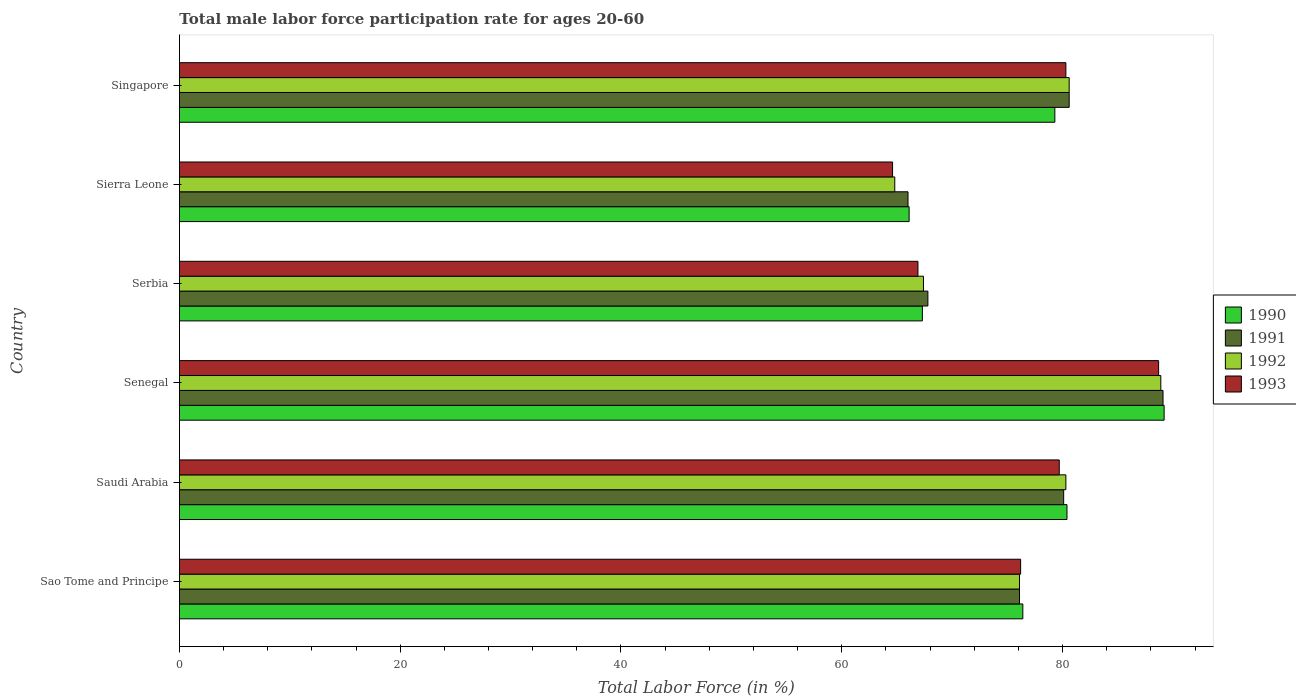Are the number of bars per tick equal to the number of legend labels?
Give a very brief answer. Yes. Are the number of bars on each tick of the Y-axis equal?
Your answer should be compact. Yes. How many bars are there on the 6th tick from the top?
Offer a terse response. 4. How many bars are there on the 3rd tick from the bottom?
Your answer should be compact. 4. What is the label of the 4th group of bars from the top?
Make the answer very short. Senegal. What is the male labor force participation rate in 1992 in Senegal?
Offer a terse response. 88.9. Across all countries, what is the maximum male labor force participation rate in 1992?
Offer a terse response. 88.9. Across all countries, what is the minimum male labor force participation rate in 1993?
Offer a very short reply. 64.6. In which country was the male labor force participation rate in 1991 maximum?
Your answer should be very brief. Senegal. In which country was the male labor force participation rate in 1993 minimum?
Your answer should be very brief. Sierra Leone. What is the total male labor force participation rate in 1992 in the graph?
Your answer should be very brief. 458.1. What is the difference between the male labor force participation rate in 1993 in Saudi Arabia and that in Serbia?
Your response must be concise. 12.8. What is the difference between the male labor force participation rate in 1993 in Senegal and the male labor force participation rate in 1990 in Singapore?
Offer a very short reply. 9.4. What is the average male labor force participation rate in 1992 per country?
Your response must be concise. 76.35. What is the difference between the male labor force participation rate in 1990 and male labor force participation rate in 1992 in Singapore?
Your response must be concise. -1.3. What is the ratio of the male labor force participation rate in 1991 in Senegal to that in Singapore?
Provide a succinct answer. 1.11. Is the difference between the male labor force participation rate in 1990 in Sierra Leone and Singapore greater than the difference between the male labor force participation rate in 1992 in Sierra Leone and Singapore?
Provide a succinct answer. Yes. What is the difference between the highest and the lowest male labor force participation rate in 1993?
Offer a very short reply. 24.1. In how many countries, is the male labor force participation rate in 1990 greater than the average male labor force participation rate in 1990 taken over all countries?
Your answer should be compact. 3. Is it the case that in every country, the sum of the male labor force participation rate in 1991 and male labor force participation rate in 1990 is greater than the sum of male labor force participation rate in 1993 and male labor force participation rate in 1992?
Make the answer very short. No. What does the 4th bar from the bottom in Sierra Leone represents?
Your answer should be very brief. 1993. Is it the case that in every country, the sum of the male labor force participation rate in 1991 and male labor force participation rate in 1992 is greater than the male labor force participation rate in 1993?
Provide a succinct answer. Yes. Are all the bars in the graph horizontal?
Offer a very short reply. Yes. What is the difference between two consecutive major ticks on the X-axis?
Ensure brevity in your answer.  20. Does the graph contain any zero values?
Your answer should be compact. No. What is the title of the graph?
Your answer should be very brief. Total male labor force participation rate for ages 20-60. Does "1975" appear as one of the legend labels in the graph?
Your response must be concise. No. What is the label or title of the Y-axis?
Give a very brief answer. Country. What is the Total Labor Force (in %) in 1990 in Sao Tome and Principe?
Offer a very short reply. 76.4. What is the Total Labor Force (in %) of 1991 in Sao Tome and Principe?
Provide a succinct answer. 76.1. What is the Total Labor Force (in %) of 1992 in Sao Tome and Principe?
Keep it short and to the point. 76.1. What is the Total Labor Force (in %) of 1993 in Sao Tome and Principe?
Ensure brevity in your answer.  76.2. What is the Total Labor Force (in %) of 1990 in Saudi Arabia?
Offer a terse response. 80.4. What is the Total Labor Force (in %) of 1991 in Saudi Arabia?
Your answer should be very brief. 80.1. What is the Total Labor Force (in %) in 1992 in Saudi Arabia?
Ensure brevity in your answer.  80.3. What is the Total Labor Force (in %) in 1993 in Saudi Arabia?
Your answer should be very brief. 79.7. What is the Total Labor Force (in %) in 1990 in Senegal?
Provide a short and direct response. 89.2. What is the Total Labor Force (in %) of 1991 in Senegal?
Ensure brevity in your answer.  89.1. What is the Total Labor Force (in %) in 1992 in Senegal?
Provide a short and direct response. 88.9. What is the Total Labor Force (in %) in 1993 in Senegal?
Offer a very short reply. 88.7. What is the Total Labor Force (in %) of 1990 in Serbia?
Your answer should be compact. 67.3. What is the Total Labor Force (in %) in 1991 in Serbia?
Keep it short and to the point. 67.8. What is the Total Labor Force (in %) of 1992 in Serbia?
Ensure brevity in your answer.  67.4. What is the Total Labor Force (in %) in 1993 in Serbia?
Your answer should be compact. 66.9. What is the Total Labor Force (in %) in 1990 in Sierra Leone?
Offer a very short reply. 66.1. What is the Total Labor Force (in %) in 1991 in Sierra Leone?
Ensure brevity in your answer.  66. What is the Total Labor Force (in %) in 1992 in Sierra Leone?
Your answer should be very brief. 64.8. What is the Total Labor Force (in %) of 1993 in Sierra Leone?
Keep it short and to the point. 64.6. What is the Total Labor Force (in %) in 1990 in Singapore?
Provide a succinct answer. 79.3. What is the Total Labor Force (in %) of 1991 in Singapore?
Give a very brief answer. 80.6. What is the Total Labor Force (in %) in 1992 in Singapore?
Make the answer very short. 80.6. What is the Total Labor Force (in %) in 1993 in Singapore?
Provide a short and direct response. 80.3. Across all countries, what is the maximum Total Labor Force (in %) of 1990?
Provide a succinct answer. 89.2. Across all countries, what is the maximum Total Labor Force (in %) of 1991?
Make the answer very short. 89.1. Across all countries, what is the maximum Total Labor Force (in %) of 1992?
Offer a terse response. 88.9. Across all countries, what is the maximum Total Labor Force (in %) in 1993?
Provide a short and direct response. 88.7. Across all countries, what is the minimum Total Labor Force (in %) in 1990?
Your answer should be compact. 66.1. Across all countries, what is the minimum Total Labor Force (in %) in 1992?
Offer a terse response. 64.8. Across all countries, what is the minimum Total Labor Force (in %) of 1993?
Ensure brevity in your answer.  64.6. What is the total Total Labor Force (in %) of 1990 in the graph?
Provide a succinct answer. 458.7. What is the total Total Labor Force (in %) of 1991 in the graph?
Provide a succinct answer. 459.7. What is the total Total Labor Force (in %) in 1992 in the graph?
Ensure brevity in your answer.  458.1. What is the total Total Labor Force (in %) of 1993 in the graph?
Ensure brevity in your answer.  456.4. What is the difference between the Total Labor Force (in %) in 1990 in Sao Tome and Principe and that in Saudi Arabia?
Give a very brief answer. -4. What is the difference between the Total Labor Force (in %) in 1991 in Sao Tome and Principe and that in Saudi Arabia?
Ensure brevity in your answer.  -4. What is the difference between the Total Labor Force (in %) in 1993 in Sao Tome and Principe and that in Saudi Arabia?
Make the answer very short. -3.5. What is the difference between the Total Labor Force (in %) in 1991 in Sao Tome and Principe and that in Senegal?
Your response must be concise. -13. What is the difference between the Total Labor Force (in %) in 1990 in Sao Tome and Principe and that in Serbia?
Provide a short and direct response. 9.1. What is the difference between the Total Labor Force (in %) in 1991 in Sao Tome and Principe and that in Serbia?
Offer a terse response. 8.3. What is the difference between the Total Labor Force (in %) in 1990 in Sao Tome and Principe and that in Sierra Leone?
Your answer should be compact. 10.3. What is the difference between the Total Labor Force (in %) in 1991 in Sao Tome and Principe and that in Sierra Leone?
Your response must be concise. 10.1. What is the difference between the Total Labor Force (in %) of 1992 in Sao Tome and Principe and that in Sierra Leone?
Keep it short and to the point. 11.3. What is the difference between the Total Labor Force (in %) in 1993 in Sao Tome and Principe and that in Sierra Leone?
Keep it short and to the point. 11.6. What is the difference between the Total Labor Force (in %) in 1990 in Sao Tome and Principe and that in Singapore?
Provide a short and direct response. -2.9. What is the difference between the Total Labor Force (in %) in 1991 in Saudi Arabia and that in Senegal?
Make the answer very short. -9. What is the difference between the Total Labor Force (in %) of 1992 in Saudi Arabia and that in Senegal?
Provide a short and direct response. -8.6. What is the difference between the Total Labor Force (in %) in 1993 in Saudi Arabia and that in Senegal?
Your answer should be compact. -9. What is the difference between the Total Labor Force (in %) of 1990 in Saudi Arabia and that in Serbia?
Ensure brevity in your answer.  13.1. What is the difference between the Total Labor Force (in %) in 1993 in Saudi Arabia and that in Serbia?
Your response must be concise. 12.8. What is the difference between the Total Labor Force (in %) in 1990 in Saudi Arabia and that in Sierra Leone?
Your answer should be compact. 14.3. What is the difference between the Total Labor Force (in %) in 1992 in Saudi Arabia and that in Sierra Leone?
Your response must be concise. 15.5. What is the difference between the Total Labor Force (in %) of 1993 in Saudi Arabia and that in Sierra Leone?
Provide a succinct answer. 15.1. What is the difference between the Total Labor Force (in %) in 1992 in Saudi Arabia and that in Singapore?
Ensure brevity in your answer.  -0.3. What is the difference between the Total Labor Force (in %) in 1993 in Saudi Arabia and that in Singapore?
Your answer should be very brief. -0.6. What is the difference between the Total Labor Force (in %) of 1990 in Senegal and that in Serbia?
Offer a terse response. 21.9. What is the difference between the Total Labor Force (in %) of 1991 in Senegal and that in Serbia?
Provide a succinct answer. 21.3. What is the difference between the Total Labor Force (in %) in 1992 in Senegal and that in Serbia?
Give a very brief answer. 21.5. What is the difference between the Total Labor Force (in %) in 1993 in Senegal and that in Serbia?
Your answer should be very brief. 21.8. What is the difference between the Total Labor Force (in %) in 1990 in Senegal and that in Sierra Leone?
Your answer should be compact. 23.1. What is the difference between the Total Labor Force (in %) of 1991 in Senegal and that in Sierra Leone?
Offer a very short reply. 23.1. What is the difference between the Total Labor Force (in %) of 1992 in Senegal and that in Sierra Leone?
Ensure brevity in your answer.  24.1. What is the difference between the Total Labor Force (in %) of 1993 in Senegal and that in Sierra Leone?
Make the answer very short. 24.1. What is the difference between the Total Labor Force (in %) in 1992 in Senegal and that in Singapore?
Ensure brevity in your answer.  8.3. What is the difference between the Total Labor Force (in %) in 1990 in Serbia and that in Sierra Leone?
Your answer should be very brief. 1.2. What is the difference between the Total Labor Force (in %) in 1992 in Serbia and that in Sierra Leone?
Give a very brief answer. 2.6. What is the difference between the Total Labor Force (in %) of 1993 in Serbia and that in Sierra Leone?
Your response must be concise. 2.3. What is the difference between the Total Labor Force (in %) of 1991 in Serbia and that in Singapore?
Give a very brief answer. -12.8. What is the difference between the Total Labor Force (in %) in 1993 in Serbia and that in Singapore?
Give a very brief answer. -13.4. What is the difference between the Total Labor Force (in %) of 1990 in Sierra Leone and that in Singapore?
Your answer should be compact. -13.2. What is the difference between the Total Labor Force (in %) of 1991 in Sierra Leone and that in Singapore?
Ensure brevity in your answer.  -14.6. What is the difference between the Total Labor Force (in %) in 1992 in Sierra Leone and that in Singapore?
Your answer should be very brief. -15.8. What is the difference between the Total Labor Force (in %) of 1993 in Sierra Leone and that in Singapore?
Your answer should be very brief. -15.7. What is the difference between the Total Labor Force (in %) in 1990 in Sao Tome and Principe and the Total Labor Force (in %) in 1991 in Saudi Arabia?
Provide a short and direct response. -3.7. What is the difference between the Total Labor Force (in %) in 1990 in Sao Tome and Principe and the Total Labor Force (in %) in 1992 in Saudi Arabia?
Keep it short and to the point. -3.9. What is the difference between the Total Labor Force (in %) in 1991 in Sao Tome and Principe and the Total Labor Force (in %) in 1992 in Saudi Arabia?
Provide a succinct answer. -4.2. What is the difference between the Total Labor Force (in %) in 1990 in Sao Tome and Principe and the Total Labor Force (in %) in 1992 in Senegal?
Provide a succinct answer. -12.5. What is the difference between the Total Labor Force (in %) of 1990 in Sao Tome and Principe and the Total Labor Force (in %) of 1992 in Serbia?
Make the answer very short. 9. What is the difference between the Total Labor Force (in %) of 1991 in Sao Tome and Principe and the Total Labor Force (in %) of 1992 in Serbia?
Your answer should be compact. 8.7. What is the difference between the Total Labor Force (in %) in 1991 in Sao Tome and Principe and the Total Labor Force (in %) in 1993 in Serbia?
Your answer should be compact. 9.2. What is the difference between the Total Labor Force (in %) in 1990 in Sao Tome and Principe and the Total Labor Force (in %) in 1991 in Sierra Leone?
Provide a short and direct response. 10.4. What is the difference between the Total Labor Force (in %) in 1991 in Sao Tome and Principe and the Total Labor Force (in %) in 1993 in Sierra Leone?
Give a very brief answer. 11.5. What is the difference between the Total Labor Force (in %) of 1992 in Sao Tome and Principe and the Total Labor Force (in %) of 1993 in Sierra Leone?
Give a very brief answer. 11.5. What is the difference between the Total Labor Force (in %) of 1990 in Sao Tome and Principe and the Total Labor Force (in %) of 1991 in Singapore?
Provide a short and direct response. -4.2. What is the difference between the Total Labor Force (in %) of 1990 in Sao Tome and Principe and the Total Labor Force (in %) of 1992 in Singapore?
Your answer should be very brief. -4.2. What is the difference between the Total Labor Force (in %) of 1992 in Sao Tome and Principe and the Total Labor Force (in %) of 1993 in Singapore?
Provide a short and direct response. -4.2. What is the difference between the Total Labor Force (in %) in 1990 in Saudi Arabia and the Total Labor Force (in %) in 1992 in Senegal?
Keep it short and to the point. -8.5. What is the difference between the Total Labor Force (in %) in 1990 in Saudi Arabia and the Total Labor Force (in %) in 1993 in Senegal?
Your answer should be very brief. -8.3. What is the difference between the Total Labor Force (in %) in 1991 in Saudi Arabia and the Total Labor Force (in %) in 1993 in Senegal?
Provide a succinct answer. -8.6. What is the difference between the Total Labor Force (in %) of 1992 in Saudi Arabia and the Total Labor Force (in %) of 1993 in Senegal?
Your answer should be very brief. -8.4. What is the difference between the Total Labor Force (in %) in 1990 in Saudi Arabia and the Total Labor Force (in %) in 1992 in Serbia?
Make the answer very short. 13. What is the difference between the Total Labor Force (in %) of 1990 in Saudi Arabia and the Total Labor Force (in %) of 1993 in Serbia?
Offer a terse response. 13.5. What is the difference between the Total Labor Force (in %) in 1991 in Saudi Arabia and the Total Labor Force (in %) in 1992 in Serbia?
Your answer should be very brief. 12.7. What is the difference between the Total Labor Force (in %) of 1991 in Saudi Arabia and the Total Labor Force (in %) of 1993 in Serbia?
Your answer should be compact. 13.2. What is the difference between the Total Labor Force (in %) in 1992 in Saudi Arabia and the Total Labor Force (in %) in 1993 in Serbia?
Your answer should be very brief. 13.4. What is the difference between the Total Labor Force (in %) of 1990 in Saudi Arabia and the Total Labor Force (in %) of 1993 in Sierra Leone?
Your answer should be compact. 15.8. What is the difference between the Total Labor Force (in %) of 1991 in Saudi Arabia and the Total Labor Force (in %) of 1992 in Sierra Leone?
Ensure brevity in your answer.  15.3. What is the difference between the Total Labor Force (in %) in 1991 in Saudi Arabia and the Total Labor Force (in %) in 1993 in Sierra Leone?
Offer a terse response. 15.5. What is the difference between the Total Labor Force (in %) of 1990 in Saudi Arabia and the Total Labor Force (in %) of 1993 in Singapore?
Provide a succinct answer. 0.1. What is the difference between the Total Labor Force (in %) in 1991 in Saudi Arabia and the Total Labor Force (in %) in 1993 in Singapore?
Your answer should be very brief. -0.2. What is the difference between the Total Labor Force (in %) of 1990 in Senegal and the Total Labor Force (in %) of 1991 in Serbia?
Your response must be concise. 21.4. What is the difference between the Total Labor Force (in %) in 1990 in Senegal and the Total Labor Force (in %) in 1992 in Serbia?
Ensure brevity in your answer.  21.8. What is the difference between the Total Labor Force (in %) in 1990 in Senegal and the Total Labor Force (in %) in 1993 in Serbia?
Keep it short and to the point. 22.3. What is the difference between the Total Labor Force (in %) in 1991 in Senegal and the Total Labor Force (in %) in 1992 in Serbia?
Provide a short and direct response. 21.7. What is the difference between the Total Labor Force (in %) in 1992 in Senegal and the Total Labor Force (in %) in 1993 in Serbia?
Keep it short and to the point. 22. What is the difference between the Total Labor Force (in %) of 1990 in Senegal and the Total Labor Force (in %) of 1991 in Sierra Leone?
Make the answer very short. 23.2. What is the difference between the Total Labor Force (in %) in 1990 in Senegal and the Total Labor Force (in %) in 1992 in Sierra Leone?
Provide a short and direct response. 24.4. What is the difference between the Total Labor Force (in %) in 1990 in Senegal and the Total Labor Force (in %) in 1993 in Sierra Leone?
Your answer should be very brief. 24.6. What is the difference between the Total Labor Force (in %) of 1991 in Senegal and the Total Labor Force (in %) of 1992 in Sierra Leone?
Ensure brevity in your answer.  24.3. What is the difference between the Total Labor Force (in %) in 1991 in Senegal and the Total Labor Force (in %) in 1993 in Sierra Leone?
Make the answer very short. 24.5. What is the difference between the Total Labor Force (in %) in 1992 in Senegal and the Total Labor Force (in %) in 1993 in Sierra Leone?
Your answer should be compact. 24.3. What is the difference between the Total Labor Force (in %) of 1990 in Senegal and the Total Labor Force (in %) of 1991 in Singapore?
Provide a succinct answer. 8.6. What is the difference between the Total Labor Force (in %) in 1990 in Senegal and the Total Labor Force (in %) in 1992 in Singapore?
Provide a short and direct response. 8.6. What is the difference between the Total Labor Force (in %) of 1990 in Senegal and the Total Labor Force (in %) of 1993 in Singapore?
Ensure brevity in your answer.  8.9. What is the difference between the Total Labor Force (in %) of 1992 in Senegal and the Total Labor Force (in %) of 1993 in Singapore?
Offer a terse response. 8.6. What is the difference between the Total Labor Force (in %) of 1991 in Serbia and the Total Labor Force (in %) of 1993 in Sierra Leone?
Your answer should be very brief. 3.2. What is the difference between the Total Labor Force (in %) of 1992 in Serbia and the Total Labor Force (in %) of 1993 in Sierra Leone?
Ensure brevity in your answer.  2.8. What is the difference between the Total Labor Force (in %) of 1990 in Serbia and the Total Labor Force (in %) of 1992 in Singapore?
Offer a very short reply. -13.3. What is the difference between the Total Labor Force (in %) of 1991 in Serbia and the Total Labor Force (in %) of 1993 in Singapore?
Offer a very short reply. -12.5. What is the difference between the Total Labor Force (in %) in 1990 in Sierra Leone and the Total Labor Force (in %) in 1991 in Singapore?
Offer a very short reply. -14.5. What is the difference between the Total Labor Force (in %) of 1990 in Sierra Leone and the Total Labor Force (in %) of 1992 in Singapore?
Offer a very short reply. -14.5. What is the difference between the Total Labor Force (in %) in 1990 in Sierra Leone and the Total Labor Force (in %) in 1993 in Singapore?
Keep it short and to the point. -14.2. What is the difference between the Total Labor Force (in %) of 1991 in Sierra Leone and the Total Labor Force (in %) of 1992 in Singapore?
Your answer should be very brief. -14.6. What is the difference between the Total Labor Force (in %) of 1991 in Sierra Leone and the Total Labor Force (in %) of 1993 in Singapore?
Offer a terse response. -14.3. What is the difference between the Total Labor Force (in %) in 1992 in Sierra Leone and the Total Labor Force (in %) in 1993 in Singapore?
Ensure brevity in your answer.  -15.5. What is the average Total Labor Force (in %) in 1990 per country?
Your answer should be very brief. 76.45. What is the average Total Labor Force (in %) in 1991 per country?
Your answer should be very brief. 76.62. What is the average Total Labor Force (in %) in 1992 per country?
Make the answer very short. 76.35. What is the average Total Labor Force (in %) of 1993 per country?
Keep it short and to the point. 76.07. What is the difference between the Total Labor Force (in %) in 1990 and Total Labor Force (in %) in 1991 in Sao Tome and Principe?
Provide a succinct answer. 0.3. What is the difference between the Total Labor Force (in %) in 1990 and Total Labor Force (in %) in 1992 in Sao Tome and Principe?
Your answer should be compact. 0.3. What is the difference between the Total Labor Force (in %) in 1990 and Total Labor Force (in %) in 1993 in Sao Tome and Principe?
Ensure brevity in your answer.  0.2. What is the difference between the Total Labor Force (in %) in 1991 and Total Labor Force (in %) in 1993 in Sao Tome and Principe?
Offer a very short reply. -0.1. What is the difference between the Total Labor Force (in %) of 1990 and Total Labor Force (in %) of 1992 in Saudi Arabia?
Give a very brief answer. 0.1. What is the difference between the Total Labor Force (in %) in 1991 and Total Labor Force (in %) in 1992 in Saudi Arabia?
Make the answer very short. -0.2. What is the difference between the Total Labor Force (in %) of 1992 and Total Labor Force (in %) of 1993 in Saudi Arabia?
Offer a very short reply. 0.6. What is the difference between the Total Labor Force (in %) of 1990 and Total Labor Force (in %) of 1991 in Senegal?
Provide a succinct answer. 0.1. What is the difference between the Total Labor Force (in %) of 1991 and Total Labor Force (in %) of 1993 in Senegal?
Provide a short and direct response. 0.4. What is the difference between the Total Labor Force (in %) of 1990 and Total Labor Force (in %) of 1991 in Serbia?
Provide a succinct answer. -0.5. What is the difference between the Total Labor Force (in %) in 1990 and Total Labor Force (in %) in 1992 in Serbia?
Your response must be concise. -0.1. What is the difference between the Total Labor Force (in %) in 1991 and Total Labor Force (in %) in 1992 in Serbia?
Your answer should be very brief. 0.4. What is the difference between the Total Labor Force (in %) in 1992 and Total Labor Force (in %) in 1993 in Serbia?
Make the answer very short. 0.5. What is the difference between the Total Labor Force (in %) in 1990 and Total Labor Force (in %) in 1991 in Sierra Leone?
Offer a terse response. 0.1. What is the difference between the Total Labor Force (in %) of 1991 and Total Labor Force (in %) of 1993 in Sierra Leone?
Your answer should be compact. 1.4. What is the difference between the Total Labor Force (in %) of 1990 and Total Labor Force (in %) of 1992 in Singapore?
Offer a very short reply. -1.3. What is the ratio of the Total Labor Force (in %) in 1990 in Sao Tome and Principe to that in Saudi Arabia?
Keep it short and to the point. 0.95. What is the ratio of the Total Labor Force (in %) in 1991 in Sao Tome and Principe to that in Saudi Arabia?
Keep it short and to the point. 0.95. What is the ratio of the Total Labor Force (in %) of 1992 in Sao Tome and Principe to that in Saudi Arabia?
Your response must be concise. 0.95. What is the ratio of the Total Labor Force (in %) of 1993 in Sao Tome and Principe to that in Saudi Arabia?
Ensure brevity in your answer.  0.96. What is the ratio of the Total Labor Force (in %) of 1990 in Sao Tome and Principe to that in Senegal?
Your response must be concise. 0.86. What is the ratio of the Total Labor Force (in %) of 1991 in Sao Tome and Principe to that in Senegal?
Make the answer very short. 0.85. What is the ratio of the Total Labor Force (in %) in 1992 in Sao Tome and Principe to that in Senegal?
Give a very brief answer. 0.86. What is the ratio of the Total Labor Force (in %) in 1993 in Sao Tome and Principe to that in Senegal?
Keep it short and to the point. 0.86. What is the ratio of the Total Labor Force (in %) in 1990 in Sao Tome and Principe to that in Serbia?
Make the answer very short. 1.14. What is the ratio of the Total Labor Force (in %) in 1991 in Sao Tome and Principe to that in Serbia?
Your answer should be very brief. 1.12. What is the ratio of the Total Labor Force (in %) in 1992 in Sao Tome and Principe to that in Serbia?
Provide a short and direct response. 1.13. What is the ratio of the Total Labor Force (in %) of 1993 in Sao Tome and Principe to that in Serbia?
Your answer should be compact. 1.14. What is the ratio of the Total Labor Force (in %) of 1990 in Sao Tome and Principe to that in Sierra Leone?
Keep it short and to the point. 1.16. What is the ratio of the Total Labor Force (in %) of 1991 in Sao Tome and Principe to that in Sierra Leone?
Offer a terse response. 1.15. What is the ratio of the Total Labor Force (in %) of 1992 in Sao Tome and Principe to that in Sierra Leone?
Make the answer very short. 1.17. What is the ratio of the Total Labor Force (in %) of 1993 in Sao Tome and Principe to that in Sierra Leone?
Offer a terse response. 1.18. What is the ratio of the Total Labor Force (in %) of 1990 in Sao Tome and Principe to that in Singapore?
Your answer should be very brief. 0.96. What is the ratio of the Total Labor Force (in %) of 1991 in Sao Tome and Principe to that in Singapore?
Keep it short and to the point. 0.94. What is the ratio of the Total Labor Force (in %) in 1992 in Sao Tome and Principe to that in Singapore?
Your response must be concise. 0.94. What is the ratio of the Total Labor Force (in %) of 1993 in Sao Tome and Principe to that in Singapore?
Your answer should be very brief. 0.95. What is the ratio of the Total Labor Force (in %) of 1990 in Saudi Arabia to that in Senegal?
Your response must be concise. 0.9. What is the ratio of the Total Labor Force (in %) in 1991 in Saudi Arabia to that in Senegal?
Offer a very short reply. 0.9. What is the ratio of the Total Labor Force (in %) of 1992 in Saudi Arabia to that in Senegal?
Give a very brief answer. 0.9. What is the ratio of the Total Labor Force (in %) of 1993 in Saudi Arabia to that in Senegal?
Offer a very short reply. 0.9. What is the ratio of the Total Labor Force (in %) of 1990 in Saudi Arabia to that in Serbia?
Keep it short and to the point. 1.19. What is the ratio of the Total Labor Force (in %) in 1991 in Saudi Arabia to that in Serbia?
Offer a very short reply. 1.18. What is the ratio of the Total Labor Force (in %) in 1992 in Saudi Arabia to that in Serbia?
Give a very brief answer. 1.19. What is the ratio of the Total Labor Force (in %) of 1993 in Saudi Arabia to that in Serbia?
Your answer should be compact. 1.19. What is the ratio of the Total Labor Force (in %) of 1990 in Saudi Arabia to that in Sierra Leone?
Provide a succinct answer. 1.22. What is the ratio of the Total Labor Force (in %) in 1991 in Saudi Arabia to that in Sierra Leone?
Keep it short and to the point. 1.21. What is the ratio of the Total Labor Force (in %) in 1992 in Saudi Arabia to that in Sierra Leone?
Offer a terse response. 1.24. What is the ratio of the Total Labor Force (in %) in 1993 in Saudi Arabia to that in Sierra Leone?
Your answer should be compact. 1.23. What is the ratio of the Total Labor Force (in %) in 1990 in Saudi Arabia to that in Singapore?
Your answer should be very brief. 1.01. What is the ratio of the Total Labor Force (in %) of 1992 in Saudi Arabia to that in Singapore?
Provide a succinct answer. 1. What is the ratio of the Total Labor Force (in %) of 1990 in Senegal to that in Serbia?
Make the answer very short. 1.33. What is the ratio of the Total Labor Force (in %) of 1991 in Senegal to that in Serbia?
Your answer should be very brief. 1.31. What is the ratio of the Total Labor Force (in %) of 1992 in Senegal to that in Serbia?
Ensure brevity in your answer.  1.32. What is the ratio of the Total Labor Force (in %) of 1993 in Senegal to that in Serbia?
Keep it short and to the point. 1.33. What is the ratio of the Total Labor Force (in %) in 1990 in Senegal to that in Sierra Leone?
Make the answer very short. 1.35. What is the ratio of the Total Labor Force (in %) in 1991 in Senegal to that in Sierra Leone?
Offer a very short reply. 1.35. What is the ratio of the Total Labor Force (in %) in 1992 in Senegal to that in Sierra Leone?
Make the answer very short. 1.37. What is the ratio of the Total Labor Force (in %) of 1993 in Senegal to that in Sierra Leone?
Ensure brevity in your answer.  1.37. What is the ratio of the Total Labor Force (in %) in 1990 in Senegal to that in Singapore?
Offer a terse response. 1.12. What is the ratio of the Total Labor Force (in %) in 1991 in Senegal to that in Singapore?
Your answer should be compact. 1.11. What is the ratio of the Total Labor Force (in %) of 1992 in Senegal to that in Singapore?
Your response must be concise. 1.1. What is the ratio of the Total Labor Force (in %) in 1993 in Senegal to that in Singapore?
Make the answer very short. 1.1. What is the ratio of the Total Labor Force (in %) of 1990 in Serbia to that in Sierra Leone?
Provide a succinct answer. 1.02. What is the ratio of the Total Labor Force (in %) in 1991 in Serbia to that in Sierra Leone?
Offer a terse response. 1.03. What is the ratio of the Total Labor Force (in %) of 1992 in Serbia to that in Sierra Leone?
Your response must be concise. 1.04. What is the ratio of the Total Labor Force (in %) of 1993 in Serbia to that in Sierra Leone?
Give a very brief answer. 1.04. What is the ratio of the Total Labor Force (in %) of 1990 in Serbia to that in Singapore?
Make the answer very short. 0.85. What is the ratio of the Total Labor Force (in %) of 1991 in Serbia to that in Singapore?
Give a very brief answer. 0.84. What is the ratio of the Total Labor Force (in %) in 1992 in Serbia to that in Singapore?
Offer a very short reply. 0.84. What is the ratio of the Total Labor Force (in %) in 1993 in Serbia to that in Singapore?
Your answer should be compact. 0.83. What is the ratio of the Total Labor Force (in %) of 1990 in Sierra Leone to that in Singapore?
Make the answer very short. 0.83. What is the ratio of the Total Labor Force (in %) in 1991 in Sierra Leone to that in Singapore?
Make the answer very short. 0.82. What is the ratio of the Total Labor Force (in %) of 1992 in Sierra Leone to that in Singapore?
Give a very brief answer. 0.8. What is the ratio of the Total Labor Force (in %) in 1993 in Sierra Leone to that in Singapore?
Keep it short and to the point. 0.8. What is the difference between the highest and the second highest Total Labor Force (in %) in 1992?
Make the answer very short. 8.3. What is the difference between the highest and the lowest Total Labor Force (in %) of 1990?
Your answer should be very brief. 23.1. What is the difference between the highest and the lowest Total Labor Force (in %) of 1991?
Your response must be concise. 23.1. What is the difference between the highest and the lowest Total Labor Force (in %) of 1992?
Provide a succinct answer. 24.1. What is the difference between the highest and the lowest Total Labor Force (in %) in 1993?
Your answer should be very brief. 24.1. 